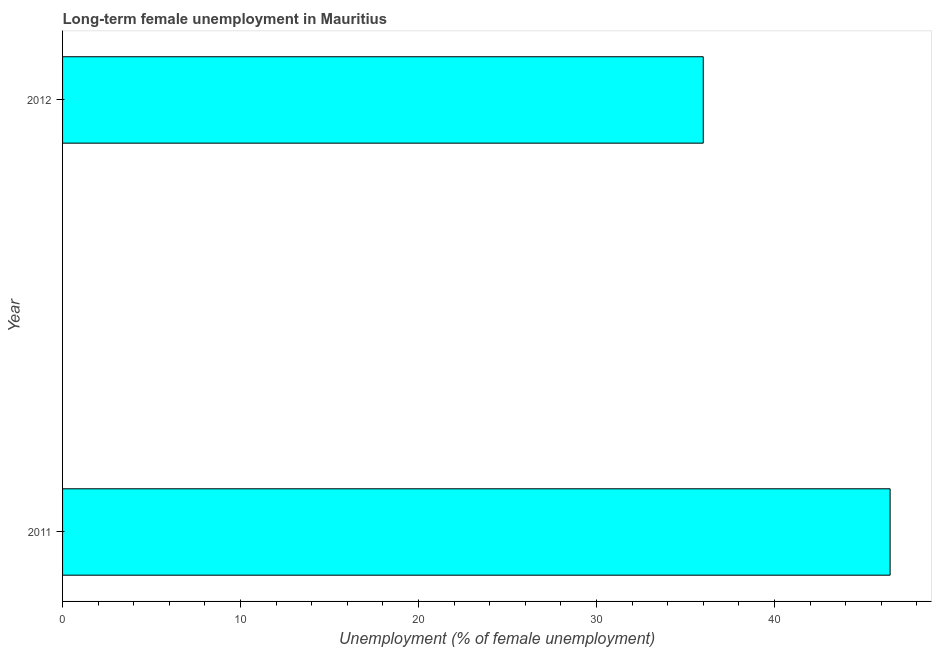What is the title of the graph?
Your response must be concise. Long-term female unemployment in Mauritius. What is the label or title of the X-axis?
Give a very brief answer. Unemployment (% of female unemployment). What is the long-term female unemployment in 2011?
Your answer should be very brief. 46.5. Across all years, what is the maximum long-term female unemployment?
Offer a terse response. 46.5. In which year was the long-term female unemployment maximum?
Your response must be concise. 2011. In which year was the long-term female unemployment minimum?
Ensure brevity in your answer.  2012. What is the sum of the long-term female unemployment?
Provide a short and direct response. 82.5. What is the difference between the long-term female unemployment in 2011 and 2012?
Keep it short and to the point. 10.5. What is the average long-term female unemployment per year?
Your response must be concise. 41.25. What is the median long-term female unemployment?
Your answer should be very brief. 41.25. In how many years, is the long-term female unemployment greater than 8 %?
Provide a short and direct response. 2. Do a majority of the years between 2011 and 2012 (inclusive) have long-term female unemployment greater than 14 %?
Ensure brevity in your answer.  Yes. What is the ratio of the long-term female unemployment in 2011 to that in 2012?
Ensure brevity in your answer.  1.29. Is the long-term female unemployment in 2011 less than that in 2012?
Make the answer very short. No. How many bars are there?
Your answer should be compact. 2. Are all the bars in the graph horizontal?
Give a very brief answer. Yes. How many years are there in the graph?
Provide a succinct answer. 2. What is the difference between two consecutive major ticks on the X-axis?
Ensure brevity in your answer.  10. Are the values on the major ticks of X-axis written in scientific E-notation?
Give a very brief answer. No. What is the Unemployment (% of female unemployment) of 2011?
Ensure brevity in your answer.  46.5. What is the difference between the Unemployment (% of female unemployment) in 2011 and 2012?
Ensure brevity in your answer.  10.5. What is the ratio of the Unemployment (% of female unemployment) in 2011 to that in 2012?
Offer a terse response. 1.29. 